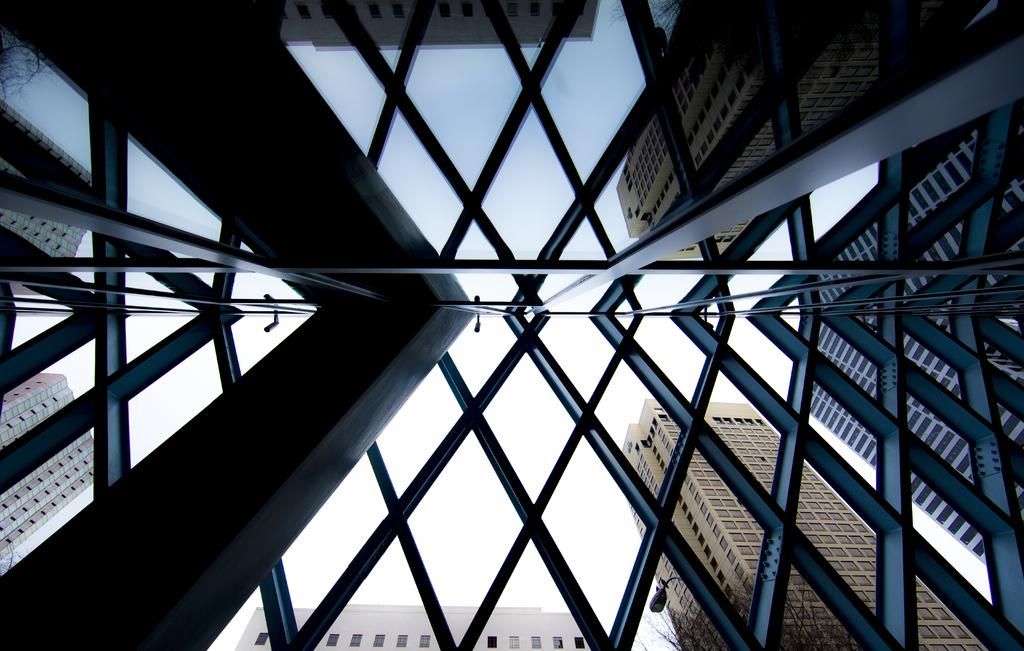What type of structures can be seen in the image? There are buildings in the image. What architectural features are present on the buildings? There are windows visible on the buildings. What is the purpose of the light pole in the image? The light pole provides illumination in the image. What type of vegetation is present in the image? There is a tree in the image. What is the condition of the sky in the image? The sky is visible in the image. What type of ice can be seen melting on the tree in the image? There is no ice present on the tree in the image. What type of net is used to catch the falling sleet in the image? There is no sleet or net present in the image. 